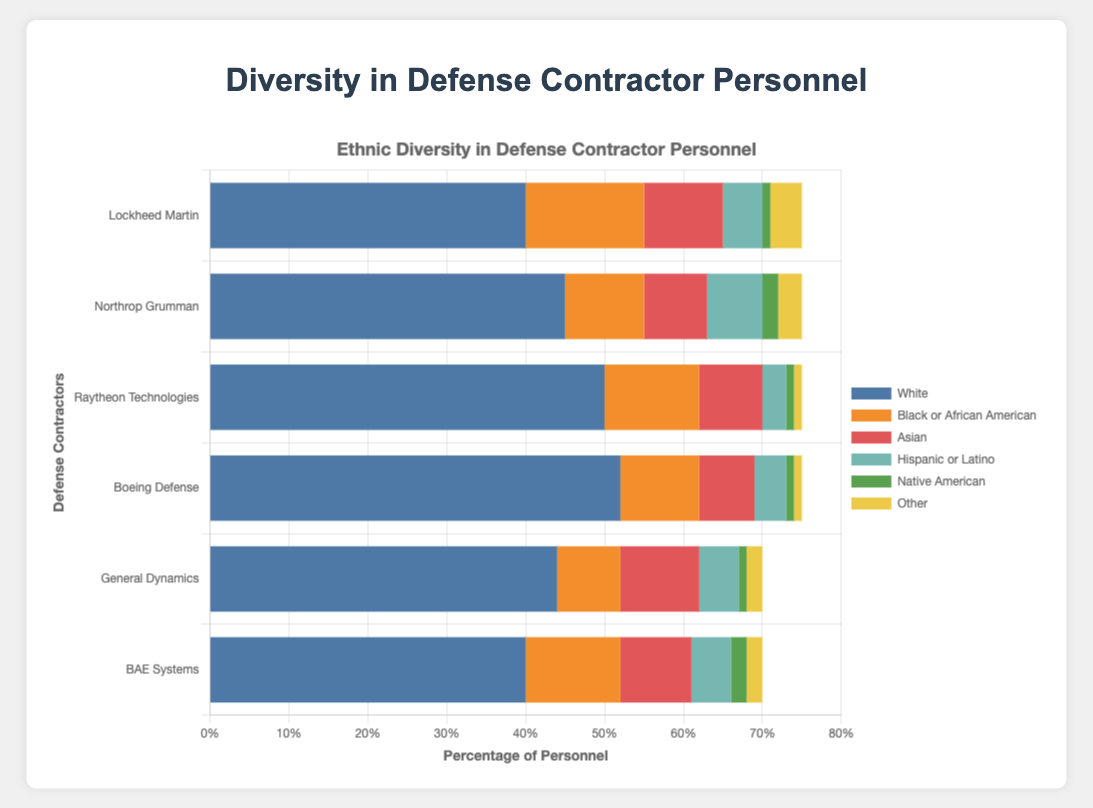What percentage of Lockheed Martin's personnel are Black or African American? Look at the horizontal bar corresponding to Lockheed Martin and identify the segment labeled "Black or African American." This segment accounts for 15% of the total personnel.
Answer: 15% Which company has the largest male personnel percentage? Compare the lengths of the "male" segments across all companies. The longest bar segment for "male" is at Boeing Defense with 60%.
Answer: Boeing Defense Among all companies, which has the smallest percentage of Hispanic or Latino personnel? Observe the "Hispanic or Latino" segments for each company. The smallest segment is for Raytheon Technologies, which is 3%.
Answer: Raytheon Technologies How does the total percentage of female personnel in General Dynamics compare to Raytheon Technologies? Add up the percentages of female personnel for General Dynamics (22%) and Raytheon Technologies (20%), and compare them. General Dynamics has a slightly higher percentage.
Answer: General Dynamics has 2% more What is the combined percentage of personnel who identify as Native American and Other in BAE Systems? Sum the percentages for Native American (2%) and Other (2%) in BAE Systems. The total is 2% + 2% = 4%.
Answer: 4% What is the percentage difference between White personnel in Lockheed Martin and Black or African American personnel in Northrop Grumman? Subtract the percentage of Black or African American personnel in Northrop Grumman (10%) from the percentage of White personnel in Lockheed Martin (40%). It is 40% - 10% = 30%.
Answer: 30% Which company has the most balanced gender distribution? Compare the percentages of male and female personnel within each company. Lockheed Martin has 45% male and 30% female, making it the most balanced among the given options.
Answer: Lockheed Martin Which ethnicity has the largest representation across all companies? Sum the percentages for each ethnicity across all companies. The "White" segments are the largest for each company, so "White" ethnicity has the largest representation overall.
Answer: White What's the total percentage of Asian personnel in Northrop Grumman and General Dynamics combined? Add the percentages of Asian personnel in Northrop Grumman (8%) and General Dynamics (10%). 8% + 10% = 18%.
Answer: 18% In which company is the percentage of Other personnel the highest? Identify and compare the "Other" segments across all companies. Lockheed Martin has the highest percentage of Other personnel with 4%.
Answer: Lockheed Martin 